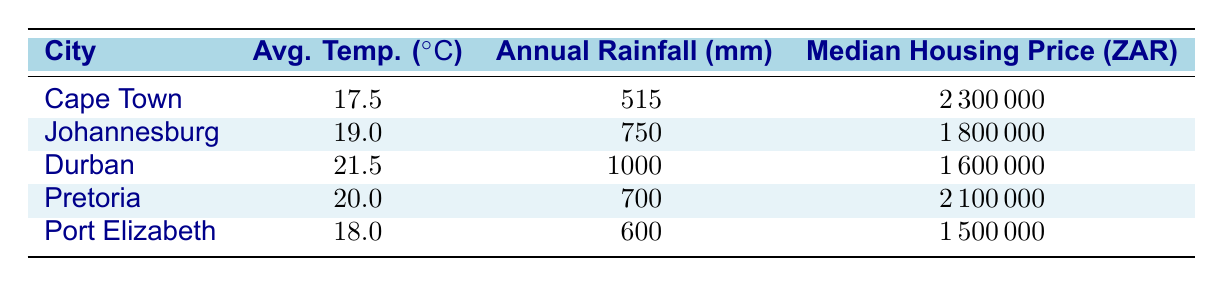What is the median housing price in Cape Town? The table lists the median housing price for each city, and for Cape Town, it is specifically mentioned as 2,300,000 ZAR.
Answer: 2,300,000 ZAR Which city has the highest average temperature? By comparing the average temperature values listed, Durban has the highest average temperature at 21.5 degrees Celsius.
Answer: Durban Is the median housing price in Pretoria higher than that in Durban? The median housing price for Pretoria is 2,100,000 ZAR, while for Durban, it is 1,600,000 ZAR. Since 2,100,000 is greater than 1,600,000, the answer is yes.
Answer: Yes What is the difference between the median housing prices of Cape Town and Port Elizabeth? Cape Town's median price is 2,300,000 ZAR and Port Elizabeth's is 1,500,000 ZAR. The difference is calculated as 2,300,000 - 1,500,000 = 800,000 ZAR.
Answer: 800,000 ZAR Which city has the lowest annual rainfall? By examining the annual rainfall column, it is clear that Cape Town has the lowest annual rainfall at 515 mm compared to other cities in the table.
Answer: Cape Town What is the average annual rainfall of Johannesburg and Pretoria combined? The annual rainfall for Johannesburg is 750 mm and for Pretoria is 700 mm. Combining these gives 750 + 700 = 1450 mm, and to find the average, we divide by 2, giving 1450 / 2 = 725 mm.
Answer: 725 mm Is there a correlation between higher average temperatures and higher median housing prices? From the data, Durban has the highest average temperature but the lowest median housing price among the cities, indicating that a higher temperature does not necessarily correlate with higher housing prices.
Answer: No What is the median housing price for the city with the second lowest annual rainfall? Looking at the annual rainfall, Cape Town has the lowest at 515 mm, followed by Port Elizabeth at 600 mm. The median housing price for Port Elizabeth is 1,500,000 ZAR.
Answer: 1,500,000 ZAR How much higher is the median housing price in Johannesburg compared to Durban? The median housing price in Johannesburg is 1,800,000 ZAR, and in Durban, it is 1,600,000 ZAR. The difference is 1,800,000 - 1,600,000 = 200,000 ZAR.
Answer: 200,000 ZAR 